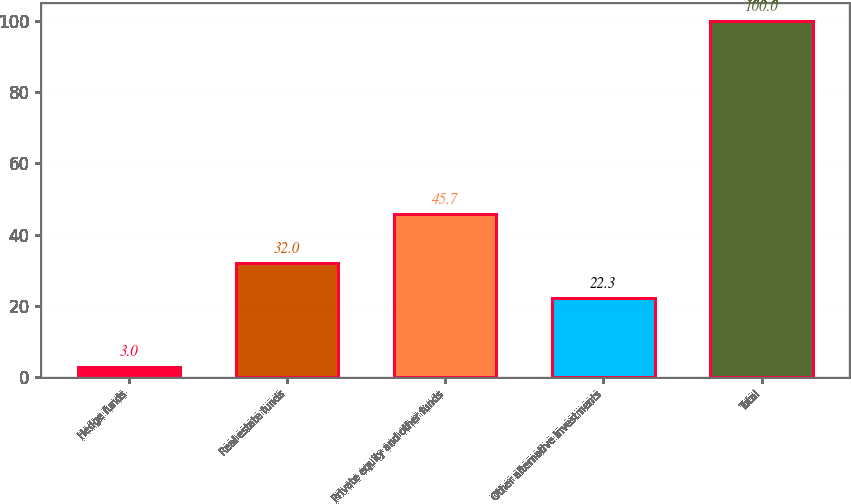Convert chart. <chart><loc_0><loc_0><loc_500><loc_500><bar_chart><fcel>Hedge funds<fcel>Real estate funds<fcel>Private equity and other funds<fcel>Other alternative investments<fcel>Total<nl><fcel>3<fcel>32<fcel>45.7<fcel>22.3<fcel>100<nl></chart> 